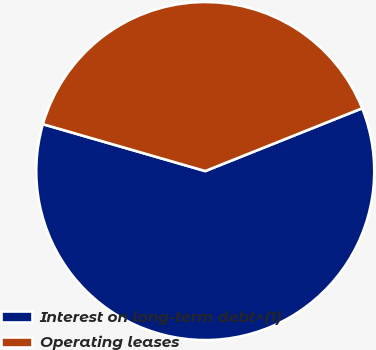<chart> <loc_0><loc_0><loc_500><loc_500><pie_chart><fcel>Interest on long-term debt^(1)<fcel>Operating leases<nl><fcel>60.53%<fcel>39.47%<nl></chart> 